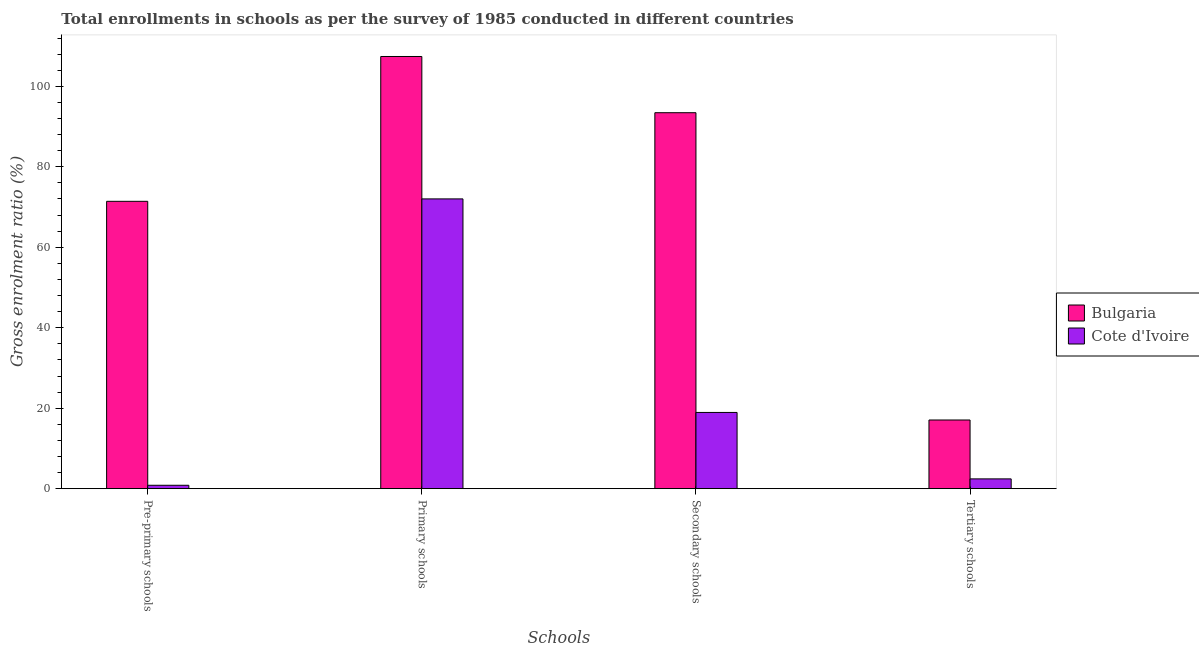Are the number of bars on each tick of the X-axis equal?
Make the answer very short. Yes. How many bars are there on the 2nd tick from the right?
Provide a succinct answer. 2. What is the label of the 4th group of bars from the left?
Provide a short and direct response. Tertiary schools. What is the gross enrolment ratio in pre-primary schools in Bulgaria?
Give a very brief answer. 71.42. Across all countries, what is the maximum gross enrolment ratio in primary schools?
Make the answer very short. 107.41. Across all countries, what is the minimum gross enrolment ratio in pre-primary schools?
Offer a terse response. 0.84. In which country was the gross enrolment ratio in secondary schools minimum?
Your answer should be very brief. Cote d'Ivoire. What is the total gross enrolment ratio in primary schools in the graph?
Give a very brief answer. 179.43. What is the difference between the gross enrolment ratio in primary schools in Cote d'Ivoire and that in Bulgaria?
Keep it short and to the point. -35.39. What is the difference between the gross enrolment ratio in pre-primary schools in Cote d'Ivoire and the gross enrolment ratio in primary schools in Bulgaria?
Ensure brevity in your answer.  -106.57. What is the average gross enrolment ratio in pre-primary schools per country?
Offer a very short reply. 36.13. What is the difference between the gross enrolment ratio in secondary schools and gross enrolment ratio in primary schools in Bulgaria?
Offer a very short reply. -13.97. In how many countries, is the gross enrolment ratio in secondary schools greater than 104 %?
Offer a terse response. 0. What is the ratio of the gross enrolment ratio in primary schools in Cote d'Ivoire to that in Bulgaria?
Your answer should be very brief. 0.67. Is the difference between the gross enrolment ratio in secondary schools in Bulgaria and Cote d'Ivoire greater than the difference between the gross enrolment ratio in tertiary schools in Bulgaria and Cote d'Ivoire?
Provide a succinct answer. Yes. What is the difference between the highest and the second highest gross enrolment ratio in primary schools?
Your answer should be very brief. 35.39. What is the difference between the highest and the lowest gross enrolment ratio in tertiary schools?
Offer a terse response. 14.64. Is the sum of the gross enrolment ratio in secondary schools in Cote d'Ivoire and Bulgaria greater than the maximum gross enrolment ratio in pre-primary schools across all countries?
Make the answer very short. Yes. Is it the case that in every country, the sum of the gross enrolment ratio in primary schools and gross enrolment ratio in secondary schools is greater than the sum of gross enrolment ratio in tertiary schools and gross enrolment ratio in pre-primary schools?
Your answer should be compact. Yes. What does the 1st bar from the left in Secondary schools represents?
Provide a succinct answer. Bulgaria. What does the 1st bar from the right in Secondary schools represents?
Keep it short and to the point. Cote d'Ivoire. Is it the case that in every country, the sum of the gross enrolment ratio in pre-primary schools and gross enrolment ratio in primary schools is greater than the gross enrolment ratio in secondary schools?
Offer a very short reply. Yes. Are all the bars in the graph horizontal?
Ensure brevity in your answer.  No. How many countries are there in the graph?
Ensure brevity in your answer.  2. What is the difference between two consecutive major ticks on the Y-axis?
Provide a succinct answer. 20. Are the values on the major ticks of Y-axis written in scientific E-notation?
Offer a terse response. No. Does the graph contain any zero values?
Offer a very short reply. No. Where does the legend appear in the graph?
Your answer should be compact. Center right. How many legend labels are there?
Your response must be concise. 2. How are the legend labels stacked?
Offer a terse response. Vertical. What is the title of the graph?
Make the answer very short. Total enrollments in schools as per the survey of 1985 conducted in different countries. What is the label or title of the X-axis?
Ensure brevity in your answer.  Schools. What is the label or title of the Y-axis?
Offer a very short reply. Gross enrolment ratio (%). What is the Gross enrolment ratio (%) of Bulgaria in Pre-primary schools?
Provide a succinct answer. 71.42. What is the Gross enrolment ratio (%) of Cote d'Ivoire in Pre-primary schools?
Your answer should be very brief. 0.84. What is the Gross enrolment ratio (%) in Bulgaria in Primary schools?
Your answer should be compact. 107.41. What is the Gross enrolment ratio (%) of Cote d'Ivoire in Primary schools?
Provide a short and direct response. 72.02. What is the Gross enrolment ratio (%) of Bulgaria in Secondary schools?
Keep it short and to the point. 93.44. What is the Gross enrolment ratio (%) of Cote d'Ivoire in Secondary schools?
Offer a very short reply. 18.94. What is the Gross enrolment ratio (%) in Bulgaria in Tertiary schools?
Offer a terse response. 17.07. What is the Gross enrolment ratio (%) in Cote d'Ivoire in Tertiary schools?
Ensure brevity in your answer.  2.43. Across all Schools, what is the maximum Gross enrolment ratio (%) of Bulgaria?
Keep it short and to the point. 107.41. Across all Schools, what is the maximum Gross enrolment ratio (%) in Cote d'Ivoire?
Provide a short and direct response. 72.02. Across all Schools, what is the minimum Gross enrolment ratio (%) of Bulgaria?
Make the answer very short. 17.07. Across all Schools, what is the minimum Gross enrolment ratio (%) in Cote d'Ivoire?
Provide a succinct answer. 0.84. What is the total Gross enrolment ratio (%) of Bulgaria in the graph?
Keep it short and to the point. 289.33. What is the total Gross enrolment ratio (%) in Cote d'Ivoire in the graph?
Ensure brevity in your answer.  94.24. What is the difference between the Gross enrolment ratio (%) in Bulgaria in Pre-primary schools and that in Primary schools?
Offer a terse response. -36. What is the difference between the Gross enrolment ratio (%) of Cote d'Ivoire in Pre-primary schools and that in Primary schools?
Keep it short and to the point. -71.17. What is the difference between the Gross enrolment ratio (%) in Bulgaria in Pre-primary schools and that in Secondary schools?
Offer a very short reply. -22.02. What is the difference between the Gross enrolment ratio (%) of Cote d'Ivoire in Pre-primary schools and that in Secondary schools?
Offer a terse response. -18.1. What is the difference between the Gross enrolment ratio (%) of Bulgaria in Pre-primary schools and that in Tertiary schools?
Offer a very short reply. 54.35. What is the difference between the Gross enrolment ratio (%) of Cote d'Ivoire in Pre-primary schools and that in Tertiary schools?
Give a very brief answer. -1.59. What is the difference between the Gross enrolment ratio (%) of Bulgaria in Primary schools and that in Secondary schools?
Keep it short and to the point. 13.97. What is the difference between the Gross enrolment ratio (%) in Cote d'Ivoire in Primary schools and that in Secondary schools?
Provide a succinct answer. 53.07. What is the difference between the Gross enrolment ratio (%) in Bulgaria in Primary schools and that in Tertiary schools?
Your answer should be very brief. 90.34. What is the difference between the Gross enrolment ratio (%) in Cote d'Ivoire in Primary schools and that in Tertiary schools?
Offer a terse response. 69.58. What is the difference between the Gross enrolment ratio (%) in Bulgaria in Secondary schools and that in Tertiary schools?
Ensure brevity in your answer.  76.37. What is the difference between the Gross enrolment ratio (%) of Cote d'Ivoire in Secondary schools and that in Tertiary schools?
Your answer should be very brief. 16.51. What is the difference between the Gross enrolment ratio (%) in Bulgaria in Pre-primary schools and the Gross enrolment ratio (%) in Cote d'Ivoire in Primary schools?
Your answer should be very brief. -0.6. What is the difference between the Gross enrolment ratio (%) of Bulgaria in Pre-primary schools and the Gross enrolment ratio (%) of Cote d'Ivoire in Secondary schools?
Your response must be concise. 52.47. What is the difference between the Gross enrolment ratio (%) in Bulgaria in Pre-primary schools and the Gross enrolment ratio (%) in Cote d'Ivoire in Tertiary schools?
Provide a short and direct response. 68.98. What is the difference between the Gross enrolment ratio (%) of Bulgaria in Primary schools and the Gross enrolment ratio (%) of Cote d'Ivoire in Secondary schools?
Provide a short and direct response. 88.47. What is the difference between the Gross enrolment ratio (%) of Bulgaria in Primary schools and the Gross enrolment ratio (%) of Cote d'Ivoire in Tertiary schools?
Offer a terse response. 104.98. What is the difference between the Gross enrolment ratio (%) of Bulgaria in Secondary schools and the Gross enrolment ratio (%) of Cote d'Ivoire in Tertiary schools?
Your answer should be compact. 91. What is the average Gross enrolment ratio (%) of Bulgaria per Schools?
Provide a succinct answer. 72.33. What is the average Gross enrolment ratio (%) of Cote d'Ivoire per Schools?
Keep it short and to the point. 23.56. What is the difference between the Gross enrolment ratio (%) of Bulgaria and Gross enrolment ratio (%) of Cote d'Ivoire in Pre-primary schools?
Your response must be concise. 70.57. What is the difference between the Gross enrolment ratio (%) in Bulgaria and Gross enrolment ratio (%) in Cote d'Ivoire in Primary schools?
Your response must be concise. 35.39. What is the difference between the Gross enrolment ratio (%) in Bulgaria and Gross enrolment ratio (%) in Cote d'Ivoire in Secondary schools?
Provide a succinct answer. 74.49. What is the difference between the Gross enrolment ratio (%) in Bulgaria and Gross enrolment ratio (%) in Cote d'Ivoire in Tertiary schools?
Offer a terse response. 14.64. What is the ratio of the Gross enrolment ratio (%) in Bulgaria in Pre-primary schools to that in Primary schools?
Ensure brevity in your answer.  0.66. What is the ratio of the Gross enrolment ratio (%) in Cote d'Ivoire in Pre-primary schools to that in Primary schools?
Your answer should be very brief. 0.01. What is the ratio of the Gross enrolment ratio (%) of Bulgaria in Pre-primary schools to that in Secondary schools?
Provide a short and direct response. 0.76. What is the ratio of the Gross enrolment ratio (%) in Cote d'Ivoire in Pre-primary schools to that in Secondary schools?
Keep it short and to the point. 0.04. What is the ratio of the Gross enrolment ratio (%) in Bulgaria in Pre-primary schools to that in Tertiary schools?
Ensure brevity in your answer.  4.18. What is the ratio of the Gross enrolment ratio (%) of Cote d'Ivoire in Pre-primary schools to that in Tertiary schools?
Ensure brevity in your answer.  0.35. What is the ratio of the Gross enrolment ratio (%) in Bulgaria in Primary schools to that in Secondary schools?
Your answer should be compact. 1.15. What is the ratio of the Gross enrolment ratio (%) in Cote d'Ivoire in Primary schools to that in Secondary schools?
Provide a succinct answer. 3.8. What is the ratio of the Gross enrolment ratio (%) of Bulgaria in Primary schools to that in Tertiary schools?
Ensure brevity in your answer.  6.29. What is the ratio of the Gross enrolment ratio (%) in Cote d'Ivoire in Primary schools to that in Tertiary schools?
Keep it short and to the point. 29.58. What is the ratio of the Gross enrolment ratio (%) in Bulgaria in Secondary schools to that in Tertiary schools?
Make the answer very short. 5.47. What is the ratio of the Gross enrolment ratio (%) in Cote d'Ivoire in Secondary schools to that in Tertiary schools?
Keep it short and to the point. 7.78. What is the difference between the highest and the second highest Gross enrolment ratio (%) of Bulgaria?
Your answer should be very brief. 13.97. What is the difference between the highest and the second highest Gross enrolment ratio (%) in Cote d'Ivoire?
Your response must be concise. 53.07. What is the difference between the highest and the lowest Gross enrolment ratio (%) in Bulgaria?
Keep it short and to the point. 90.34. What is the difference between the highest and the lowest Gross enrolment ratio (%) in Cote d'Ivoire?
Offer a very short reply. 71.17. 